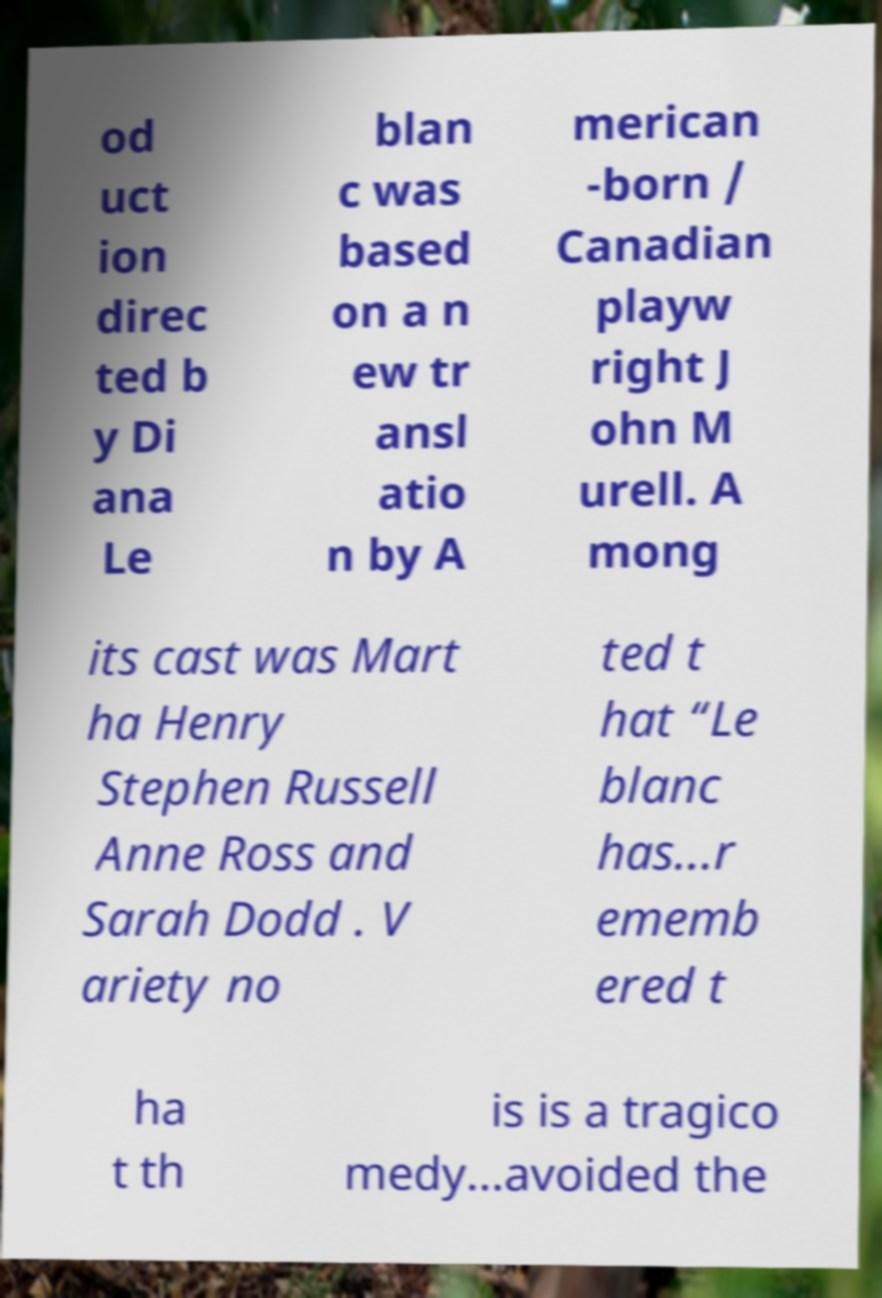Could you extract and type out the text from this image? od uct ion direc ted b y Di ana Le blan c was based on a n ew tr ansl atio n by A merican -born / Canadian playw right J ohn M urell. A mong its cast was Mart ha Henry Stephen Russell Anne Ross and Sarah Dodd . V ariety no ted t hat “Le blanc has...r ememb ered t ha t th is is a tragico medy...avoided the 